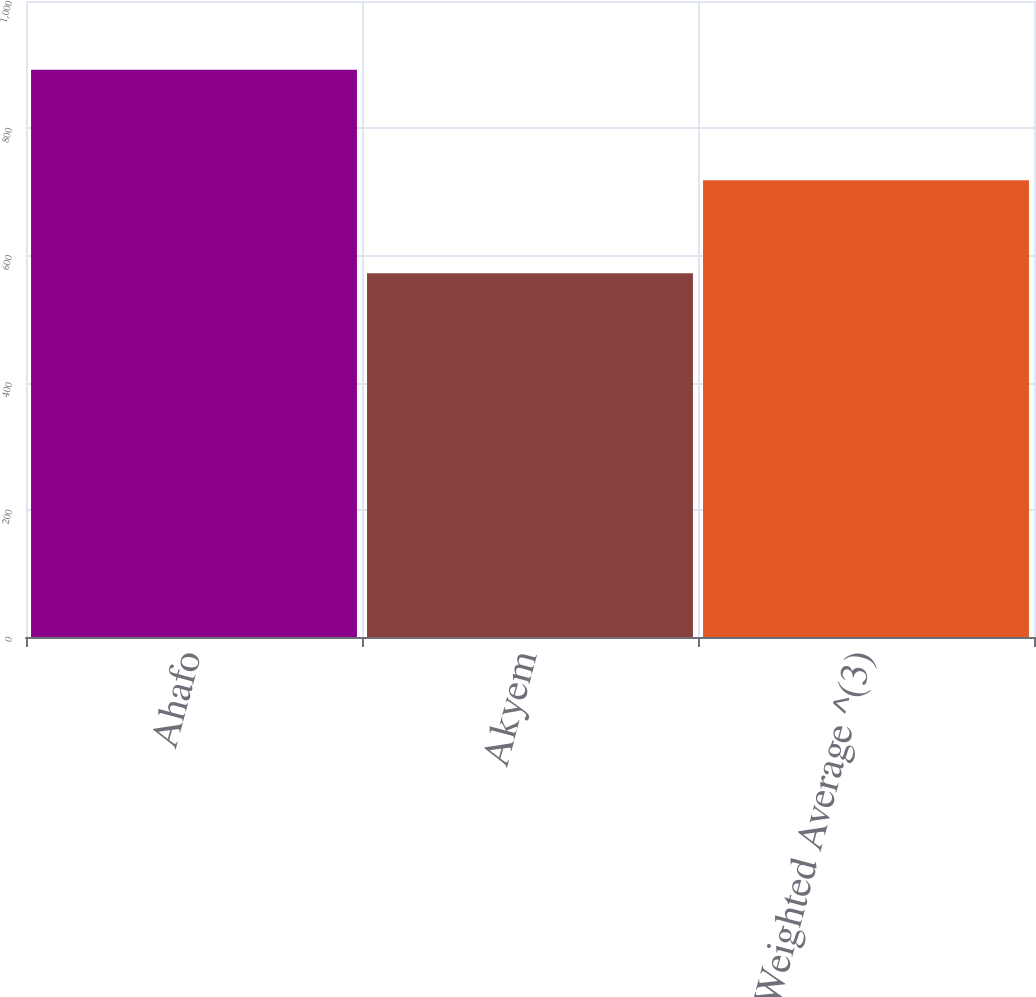<chart> <loc_0><loc_0><loc_500><loc_500><bar_chart><fcel>Ahafo<fcel>Akyem<fcel>Total / Weighted Average ^(3)<nl><fcel>892<fcel>572<fcel>718<nl></chart> 